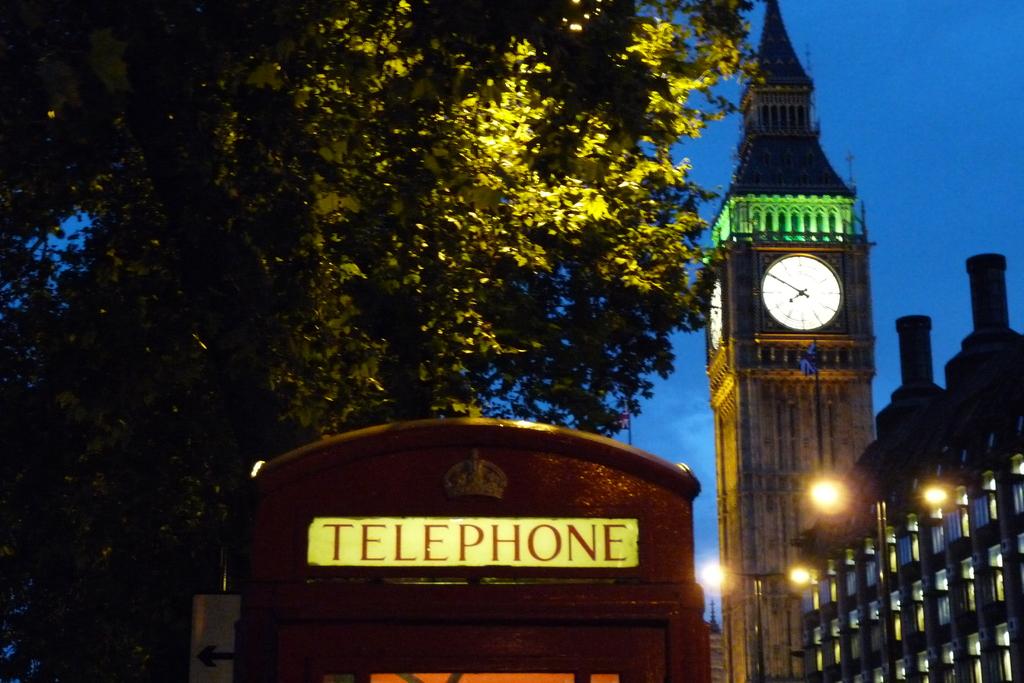Is this a telephone booth?
Keep it short and to the point. Yes. 